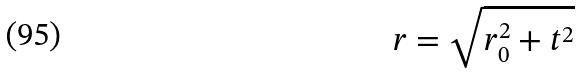Convert formula to latex. <formula><loc_0><loc_0><loc_500><loc_500>r = \sqrt { r _ { 0 } ^ { 2 } + t ^ { 2 } }</formula> 